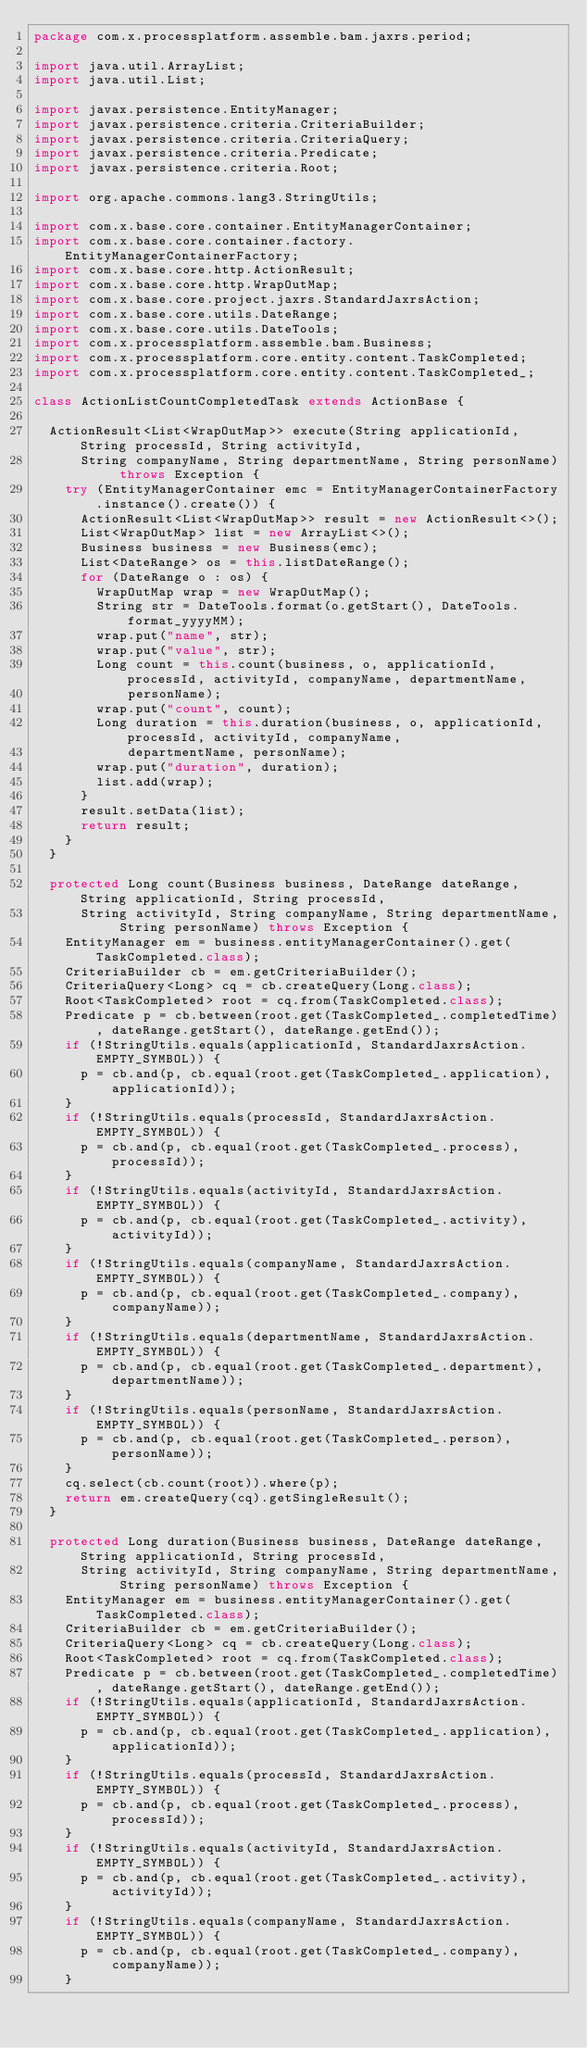Convert code to text. <code><loc_0><loc_0><loc_500><loc_500><_Java_>package com.x.processplatform.assemble.bam.jaxrs.period;

import java.util.ArrayList;
import java.util.List;

import javax.persistence.EntityManager;
import javax.persistence.criteria.CriteriaBuilder;
import javax.persistence.criteria.CriteriaQuery;
import javax.persistence.criteria.Predicate;
import javax.persistence.criteria.Root;

import org.apache.commons.lang3.StringUtils;

import com.x.base.core.container.EntityManagerContainer;
import com.x.base.core.container.factory.EntityManagerContainerFactory;
import com.x.base.core.http.ActionResult;
import com.x.base.core.http.WrapOutMap;
import com.x.base.core.project.jaxrs.StandardJaxrsAction;
import com.x.base.core.utils.DateRange;
import com.x.base.core.utils.DateTools;
import com.x.processplatform.assemble.bam.Business;
import com.x.processplatform.core.entity.content.TaskCompleted;
import com.x.processplatform.core.entity.content.TaskCompleted_;

class ActionListCountCompletedTask extends ActionBase {

	ActionResult<List<WrapOutMap>> execute(String applicationId, String processId, String activityId,
			String companyName, String departmentName, String personName) throws Exception {
		try (EntityManagerContainer emc = EntityManagerContainerFactory.instance().create()) {
			ActionResult<List<WrapOutMap>> result = new ActionResult<>();
			List<WrapOutMap> list = new ArrayList<>();
			Business business = new Business(emc);
			List<DateRange> os = this.listDateRange();
			for (DateRange o : os) {
				WrapOutMap wrap = new WrapOutMap();
				String str = DateTools.format(o.getStart(), DateTools.format_yyyyMM);
				wrap.put("name", str);
				wrap.put("value", str);
				Long count = this.count(business, o, applicationId, processId, activityId, companyName, departmentName,
						personName);
				wrap.put("count", count);
				Long duration = this.duration(business, o, applicationId, processId, activityId, companyName,
						departmentName, personName);
				wrap.put("duration", duration);
				list.add(wrap);
			}
			result.setData(list);
			return result;
		}
	}

	protected Long count(Business business, DateRange dateRange, String applicationId, String processId,
			String activityId, String companyName, String departmentName, String personName) throws Exception {
		EntityManager em = business.entityManagerContainer().get(TaskCompleted.class);
		CriteriaBuilder cb = em.getCriteriaBuilder();
		CriteriaQuery<Long> cq = cb.createQuery(Long.class);
		Root<TaskCompleted> root = cq.from(TaskCompleted.class);
		Predicate p = cb.between(root.get(TaskCompleted_.completedTime), dateRange.getStart(), dateRange.getEnd());
		if (!StringUtils.equals(applicationId, StandardJaxrsAction.EMPTY_SYMBOL)) {
			p = cb.and(p, cb.equal(root.get(TaskCompleted_.application), applicationId));
		}
		if (!StringUtils.equals(processId, StandardJaxrsAction.EMPTY_SYMBOL)) {
			p = cb.and(p, cb.equal(root.get(TaskCompleted_.process), processId));
		}
		if (!StringUtils.equals(activityId, StandardJaxrsAction.EMPTY_SYMBOL)) {
			p = cb.and(p, cb.equal(root.get(TaskCompleted_.activity), activityId));
		}
		if (!StringUtils.equals(companyName, StandardJaxrsAction.EMPTY_SYMBOL)) {
			p = cb.and(p, cb.equal(root.get(TaskCompleted_.company), companyName));
		}
		if (!StringUtils.equals(departmentName, StandardJaxrsAction.EMPTY_SYMBOL)) {
			p = cb.and(p, cb.equal(root.get(TaskCompleted_.department), departmentName));
		}
		if (!StringUtils.equals(personName, StandardJaxrsAction.EMPTY_SYMBOL)) {
			p = cb.and(p, cb.equal(root.get(TaskCompleted_.person), personName));
		}
		cq.select(cb.count(root)).where(p);
		return em.createQuery(cq).getSingleResult();
	}

	protected Long duration(Business business, DateRange dateRange, String applicationId, String processId,
			String activityId, String companyName, String departmentName, String personName) throws Exception {
		EntityManager em = business.entityManagerContainer().get(TaskCompleted.class);
		CriteriaBuilder cb = em.getCriteriaBuilder();
		CriteriaQuery<Long> cq = cb.createQuery(Long.class);
		Root<TaskCompleted> root = cq.from(TaskCompleted.class);
		Predicate p = cb.between(root.get(TaskCompleted_.completedTime), dateRange.getStart(), dateRange.getEnd());
		if (!StringUtils.equals(applicationId, StandardJaxrsAction.EMPTY_SYMBOL)) {
			p = cb.and(p, cb.equal(root.get(TaskCompleted_.application), applicationId));
		}
		if (!StringUtils.equals(processId, StandardJaxrsAction.EMPTY_SYMBOL)) {
			p = cb.and(p, cb.equal(root.get(TaskCompleted_.process), processId));
		}
		if (!StringUtils.equals(activityId, StandardJaxrsAction.EMPTY_SYMBOL)) {
			p = cb.and(p, cb.equal(root.get(TaskCompleted_.activity), activityId));
		}
		if (!StringUtils.equals(companyName, StandardJaxrsAction.EMPTY_SYMBOL)) {
			p = cb.and(p, cb.equal(root.get(TaskCompleted_.company), companyName));
		}</code> 